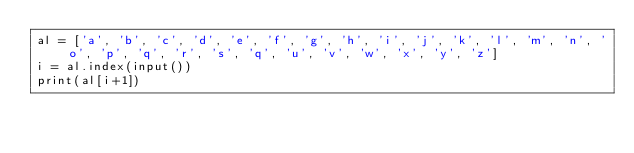Convert code to text. <code><loc_0><loc_0><loc_500><loc_500><_Python_>al = ['a', 'b', 'c', 'd', 'e', 'f', 'g', 'h', 'i', 'j', 'k', 'l', 'm', 'n', 'o', 'p', 'q', 'r', 's', 'q', 'u', 'v', 'w', 'x', 'y', 'z']
i = al.index(input())
print(al[i+1])
</code> 